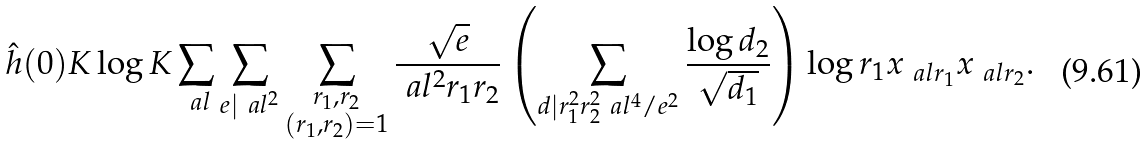Convert formula to latex. <formula><loc_0><loc_0><loc_500><loc_500>& \hat { h } ( 0 ) K \log K \sum _ { \ a l } \sum _ { e | \ a l ^ { 2 } } \sum _ { \substack { r _ { 1 } , r _ { 2 } \\ ( r _ { 1 } , r _ { 2 } ) = 1 } } \frac { \sqrt { e } } { \ a l ^ { 2 } r _ { 1 } r _ { 2 } } \left ( \sum _ { d | r _ { 1 } ^ { 2 } r _ { 2 } ^ { 2 } \ a l ^ { 4 } / e ^ { 2 } } \frac { \log d _ { 2 } } { \sqrt { d _ { 1 } } } \right ) \log r _ { 1 } x _ { \ a l r _ { 1 } } x _ { \ a l r _ { 2 } } .</formula> 